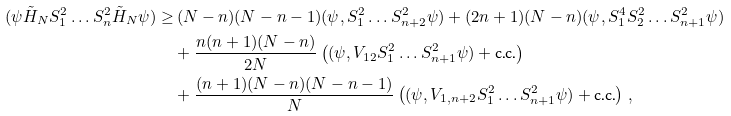<formula> <loc_0><loc_0><loc_500><loc_500>( \psi \tilde { H } _ { N } S _ { 1 } ^ { 2 } \dots S _ { n } ^ { 2 } \tilde { H } _ { N } \psi ) \geq & \, ( N - n ) ( N - n - 1 ) ( \psi , S _ { 1 } ^ { 2 } \dots S _ { n + 2 } ^ { 2 } \psi ) + ( 2 n + 1 ) ( N - n ) ( \psi , S _ { 1 } ^ { 4 } S _ { 2 } ^ { 2 } \dots S _ { n + 1 } ^ { 2 } \psi ) \\ & + \frac { n ( n + 1 ) ( N - n ) } { 2 N } \left ( ( \psi , V _ { 1 2 } S _ { 1 } ^ { 2 } \dots S _ { n + 1 } ^ { 2 } \psi ) + \text {c.c.} \right ) \\ & + \frac { ( n + 1 ) ( N - n ) ( N - n - 1 ) } { N } \left ( ( \psi , V _ { 1 , n + 2 } S _ { 1 } ^ { 2 } \dots S _ { n + 1 } ^ { 2 } \psi ) + \text {c.c.} \right ) \, ,</formula> 